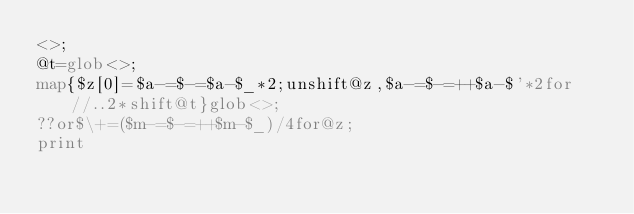Convert code to text. <code><loc_0><loc_0><loc_500><loc_500><_Perl_><>;
@t=glob<>;
map{$z[0]=$a-=$-=$a-$_*2;unshift@z,$a-=$-=++$a-$'*2for//..2*shift@t}glob<>;
??or$\+=($m-=$-=++$m-$_)/4for@z;
print</code> 